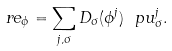<formula> <loc_0><loc_0><loc_500><loc_500>\ r e _ { \phi } = \sum _ { j , \sigma } D _ { \sigma } ( \phi ^ { j } ) \ p { u ^ { j } _ { \sigma } } .</formula> 